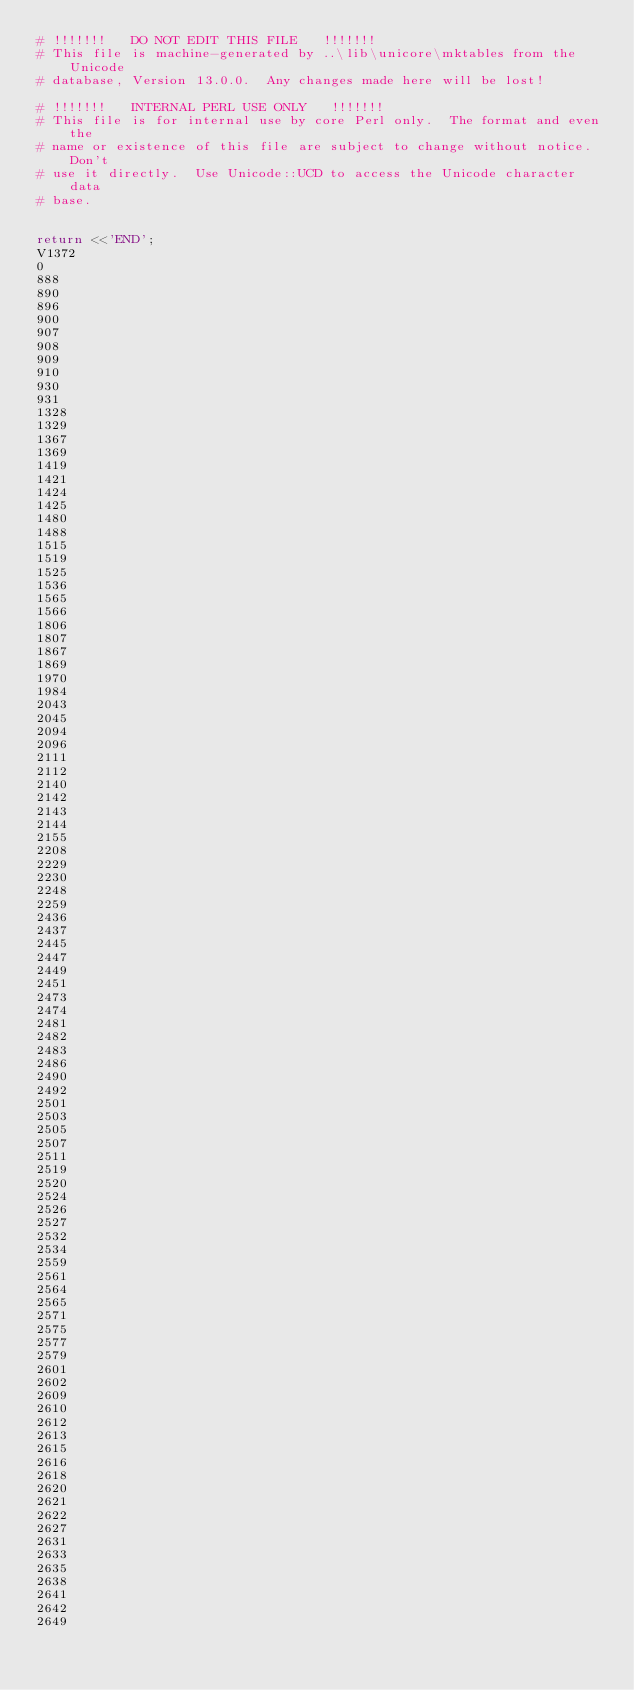Convert code to text. <code><loc_0><loc_0><loc_500><loc_500><_Perl_># !!!!!!!   DO NOT EDIT THIS FILE   !!!!!!!
# This file is machine-generated by ..\lib\unicore\mktables from the Unicode
# database, Version 13.0.0.  Any changes made here will be lost!

# !!!!!!!   INTERNAL PERL USE ONLY   !!!!!!!
# This file is for internal use by core Perl only.  The format and even the
# name or existence of this file are subject to change without notice.  Don't
# use it directly.  Use Unicode::UCD to access the Unicode character data
# base.


return <<'END';
V1372
0
888
890
896
900
907
908
909
910
930
931
1328
1329
1367
1369
1419
1421
1424
1425
1480
1488
1515
1519
1525
1536
1565
1566
1806
1807
1867
1869
1970
1984
2043
2045
2094
2096
2111
2112
2140
2142
2143
2144
2155
2208
2229
2230
2248
2259
2436
2437
2445
2447
2449
2451
2473
2474
2481
2482
2483
2486
2490
2492
2501
2503
2505
2507
2511
2519
2520
2524
2526
2527
2532
2534
2559
2561
2564
2565
2571
2575
2577
2579
2601
2602
2609
2610
2612
2613
2615
2616
2618
2620
2621
2622
2627
2631
2633
2635
2638
2641
2642
2649</code> 